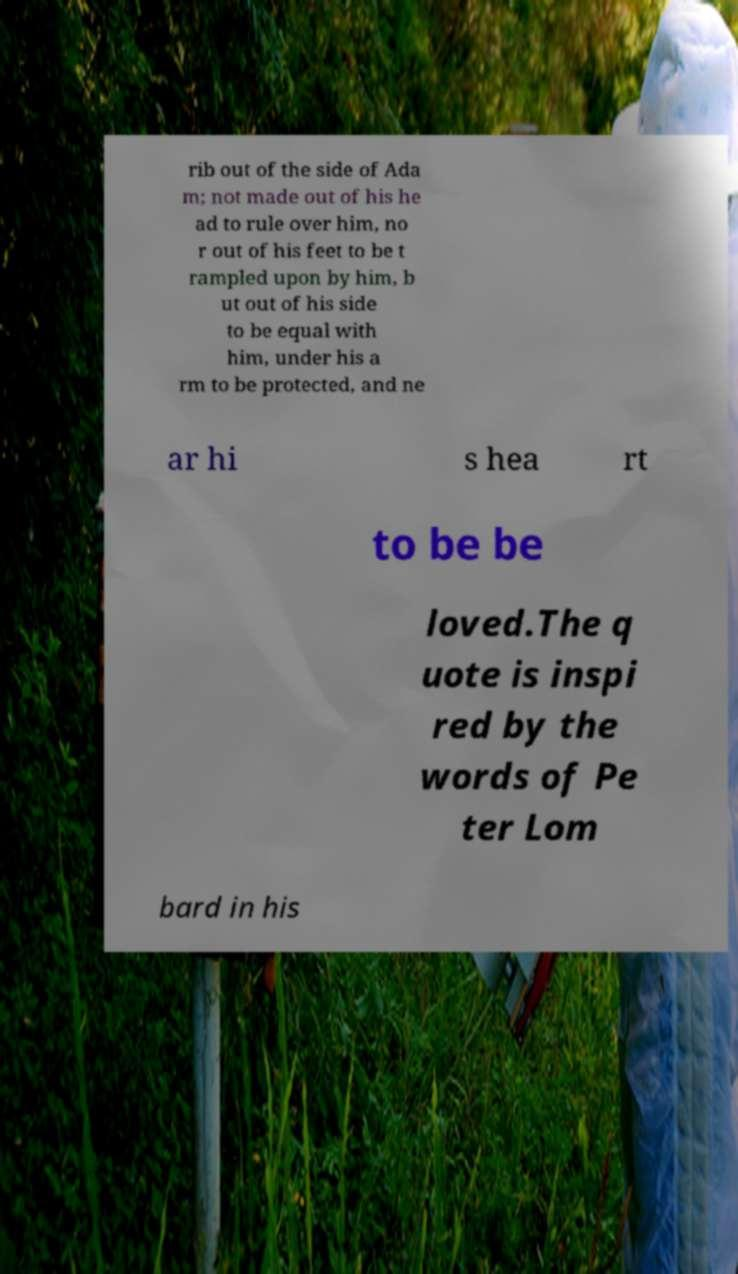Can you read and provide the text displayed in the image?This photo seems to have some interesting text. Can you extract and type it out for me? rib out of the side of Ada m; not made out of his he ad to rule over him, no r out of his feet to be t rampled upon by him, b ut out of his side to be equal with him, under his a rm to be protected, and ne ar hi s hea rt to be be loved.The q uote is inspi red by the words of Pe ter Lom bard in his 